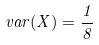<formula> <loc_0><loc_0><loc_500><loc_500>v a r ( X ) = \frac { 1 } { 8 }</formula> 